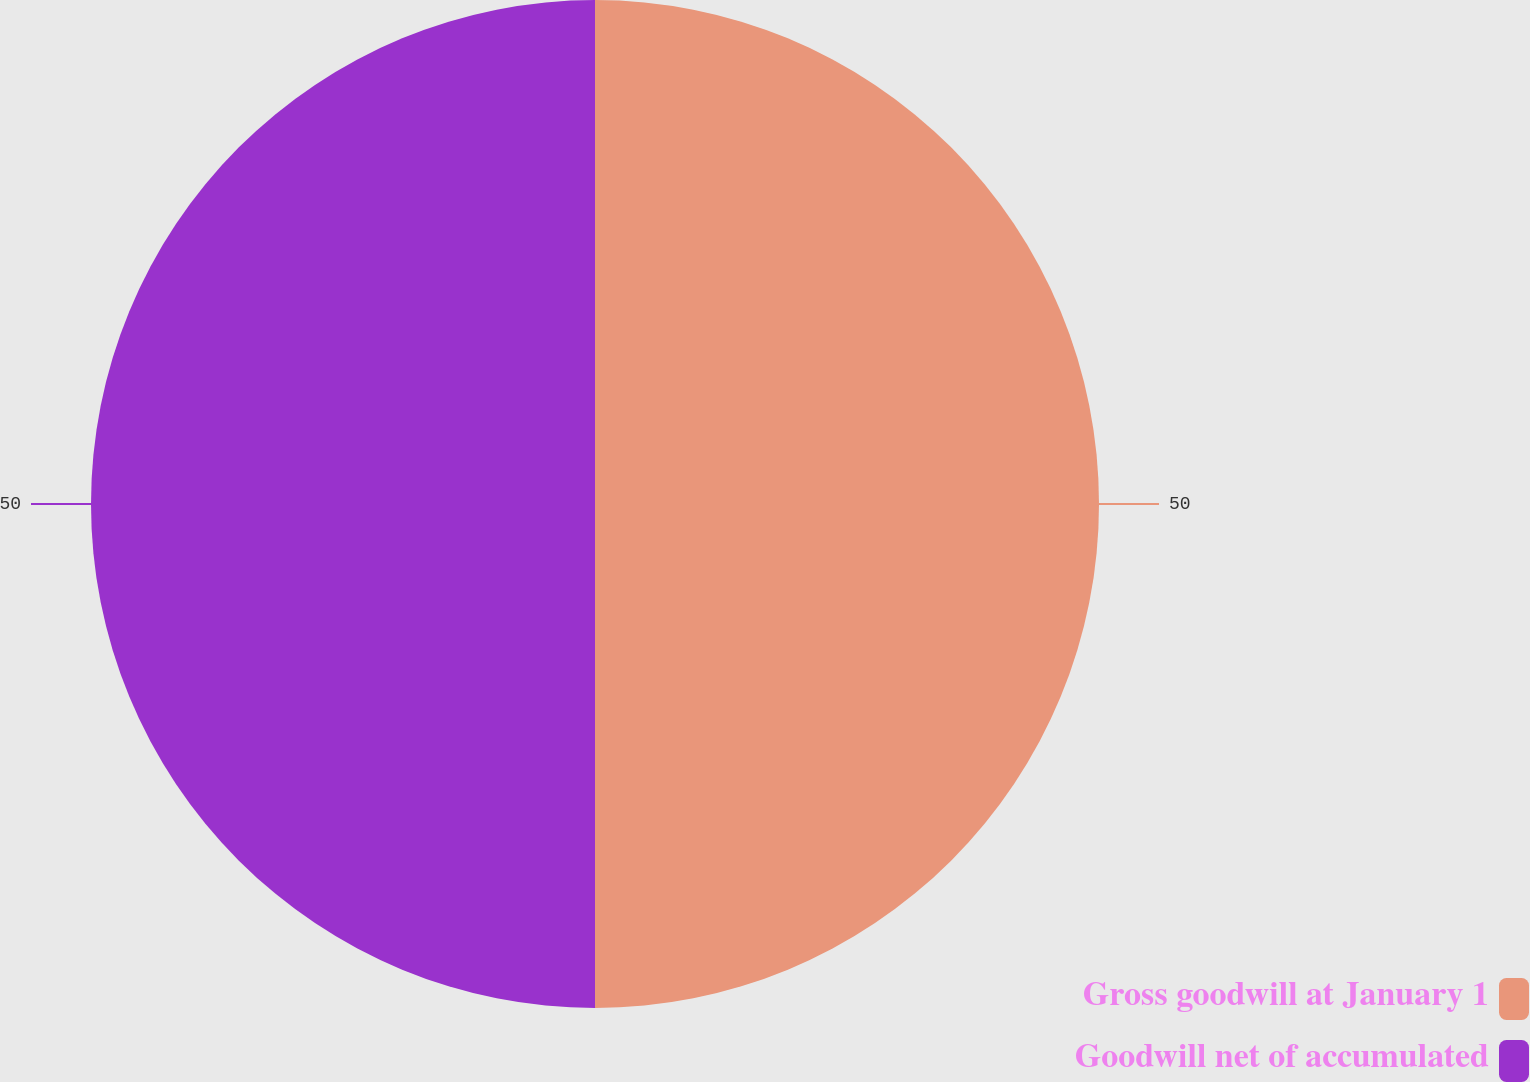Convert chart to OTSL. <chart><loc_0><loc_0><loc_500><loc_500><pie_chart><fcel>Gross goodwill at January 1<fcel>Goodwill net of accumulated<nl><fcel>50.0%<fcel>50.0%<nl></chart> 